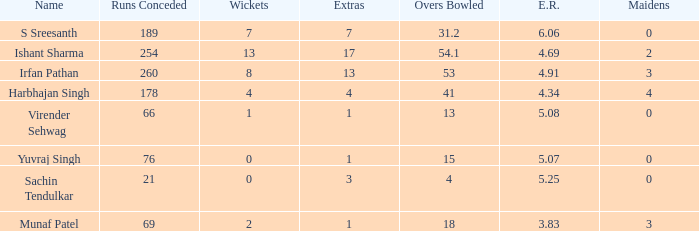Name the wickets for overs bowled being 15 0.0. 